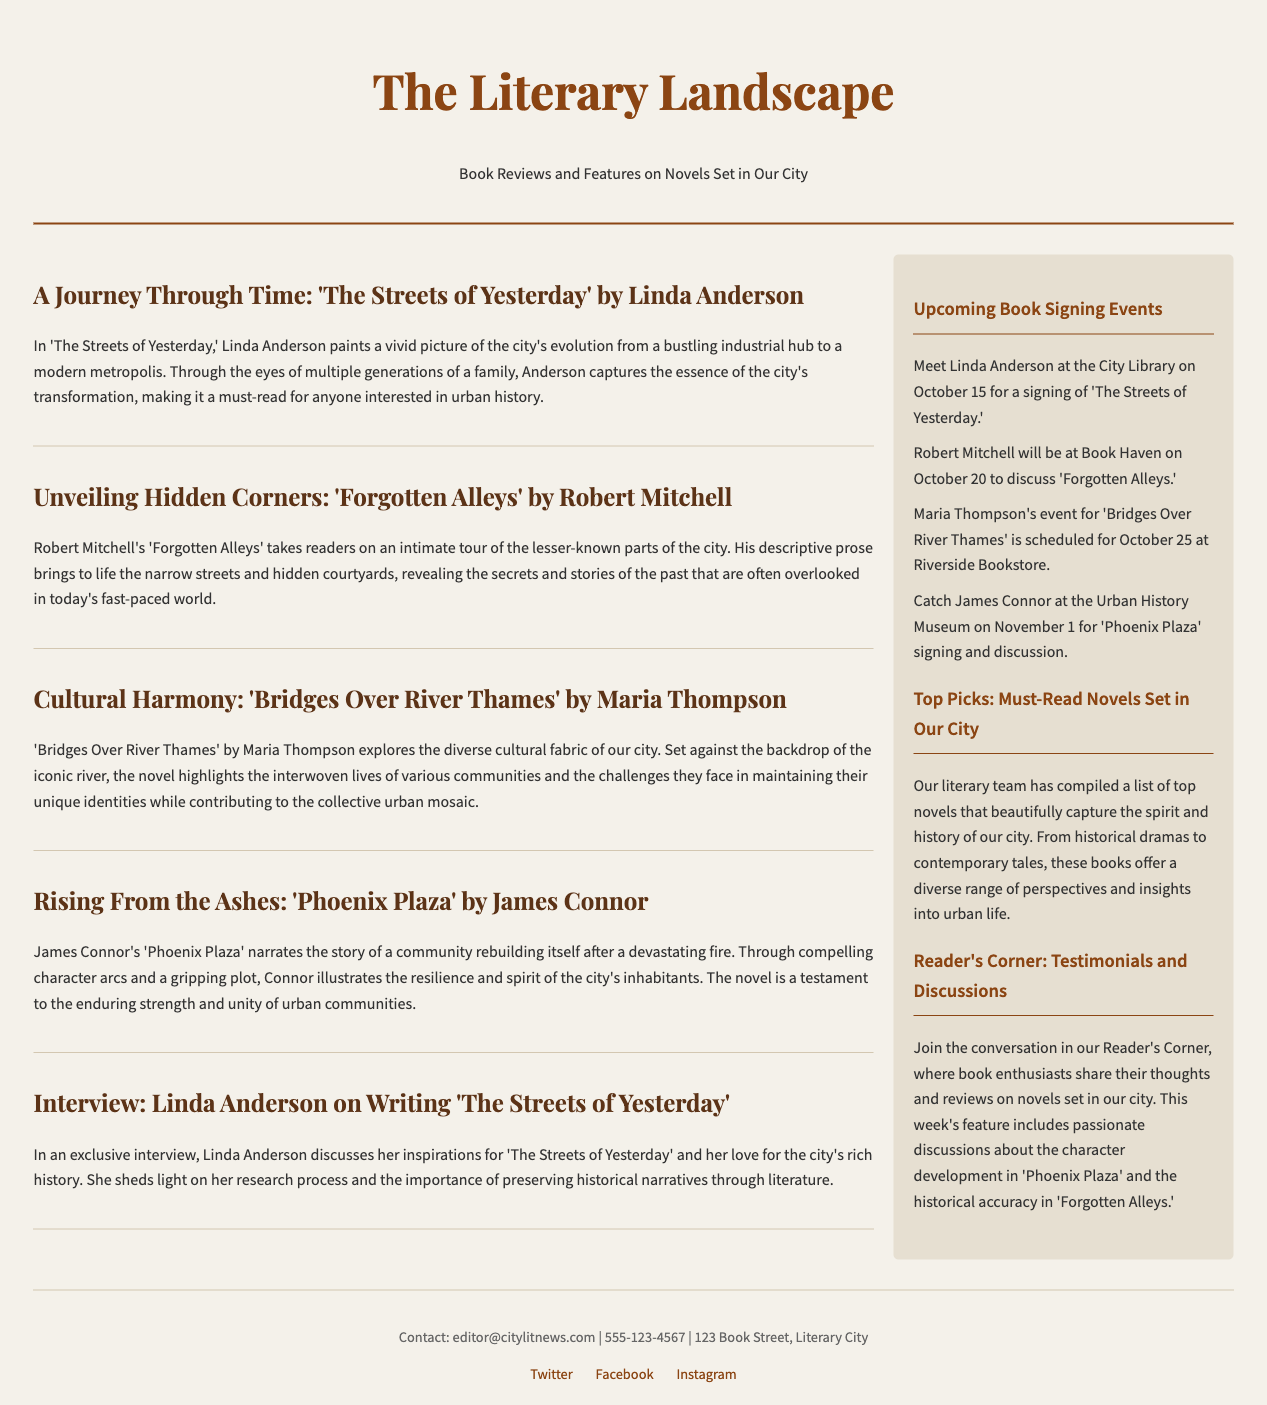What is the title of the publication? The title of the publication is prominently displayed at the top of the document.
Answer: The Literary Landscape Who is the author of 'Forgotten Alleys'? The article provides the name of the author of 'Forgotten Alleys' within the review section.
Answer: Robert Mitchell What event is scheduled for October 20? The sidebar lists upcoming events, including one on October 20.
Answer: Robert Mitchell will be at Book Haven How many articles are featured in the main content? Counting the articles listed in the main content section reveals the total number.
Answer: Four articles Which novel explores the theme of community rebuilding? The relevant article discusses the main theme of community rebuilding in one of the featured novels.
Answer: Phoenix Plaza What genre does 'Bridges Over River Thames' fall under? The content of the article hints at the novel's thematic exploration within a cultural context.
Answer: Cultural exploration What is the purpose of Reader's Corner? The sidebar describes the purpose and activities taking place in Reader's Corner.
Answer: Discussions and testimonials Who discusses their inspirations in an interview? An exclusive interview section reveals the author's name who shares insights about their work.
Answer: Linda Anderson 